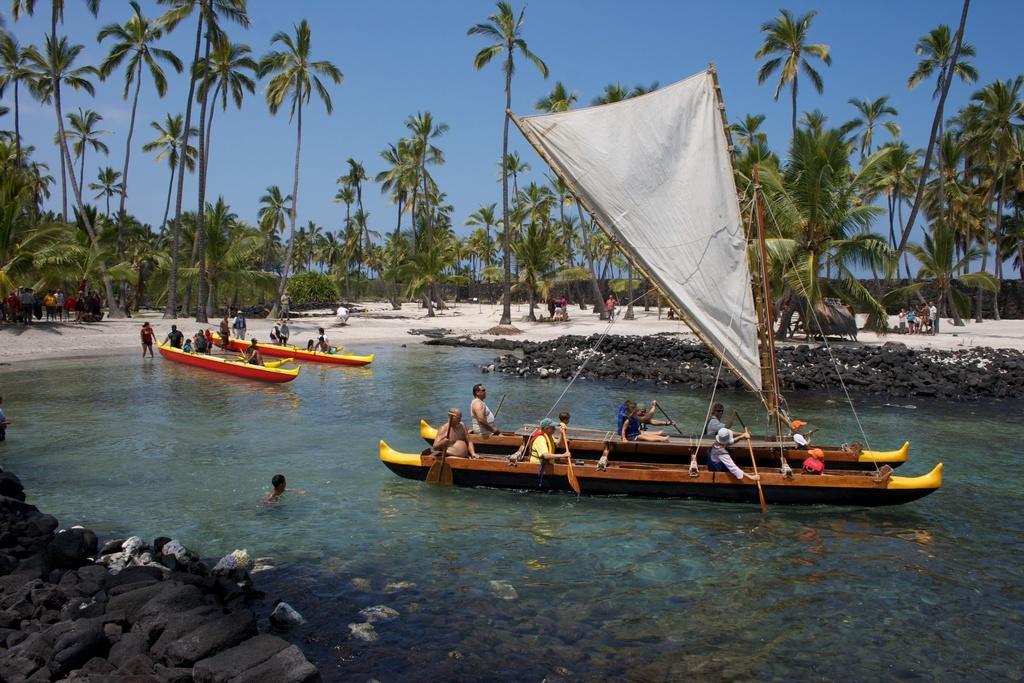Please provide a concise description of this image. In this picture we can see some men sitting in the boat and in the front there is a river water. Behind there are many coconut trees and in the front bottom side there are some rocks in the water. 